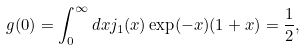Convert formula to latex. <formula><loc_0><loc_0><loc_500><loc_500>g ( 0 ) = \int _ { 0 } ^ { \infty } d x j _ { 1 } ( x ) \exp ( - x ) ( 1 + x ) = \frac { 1 } { 2 } ,</formula> 